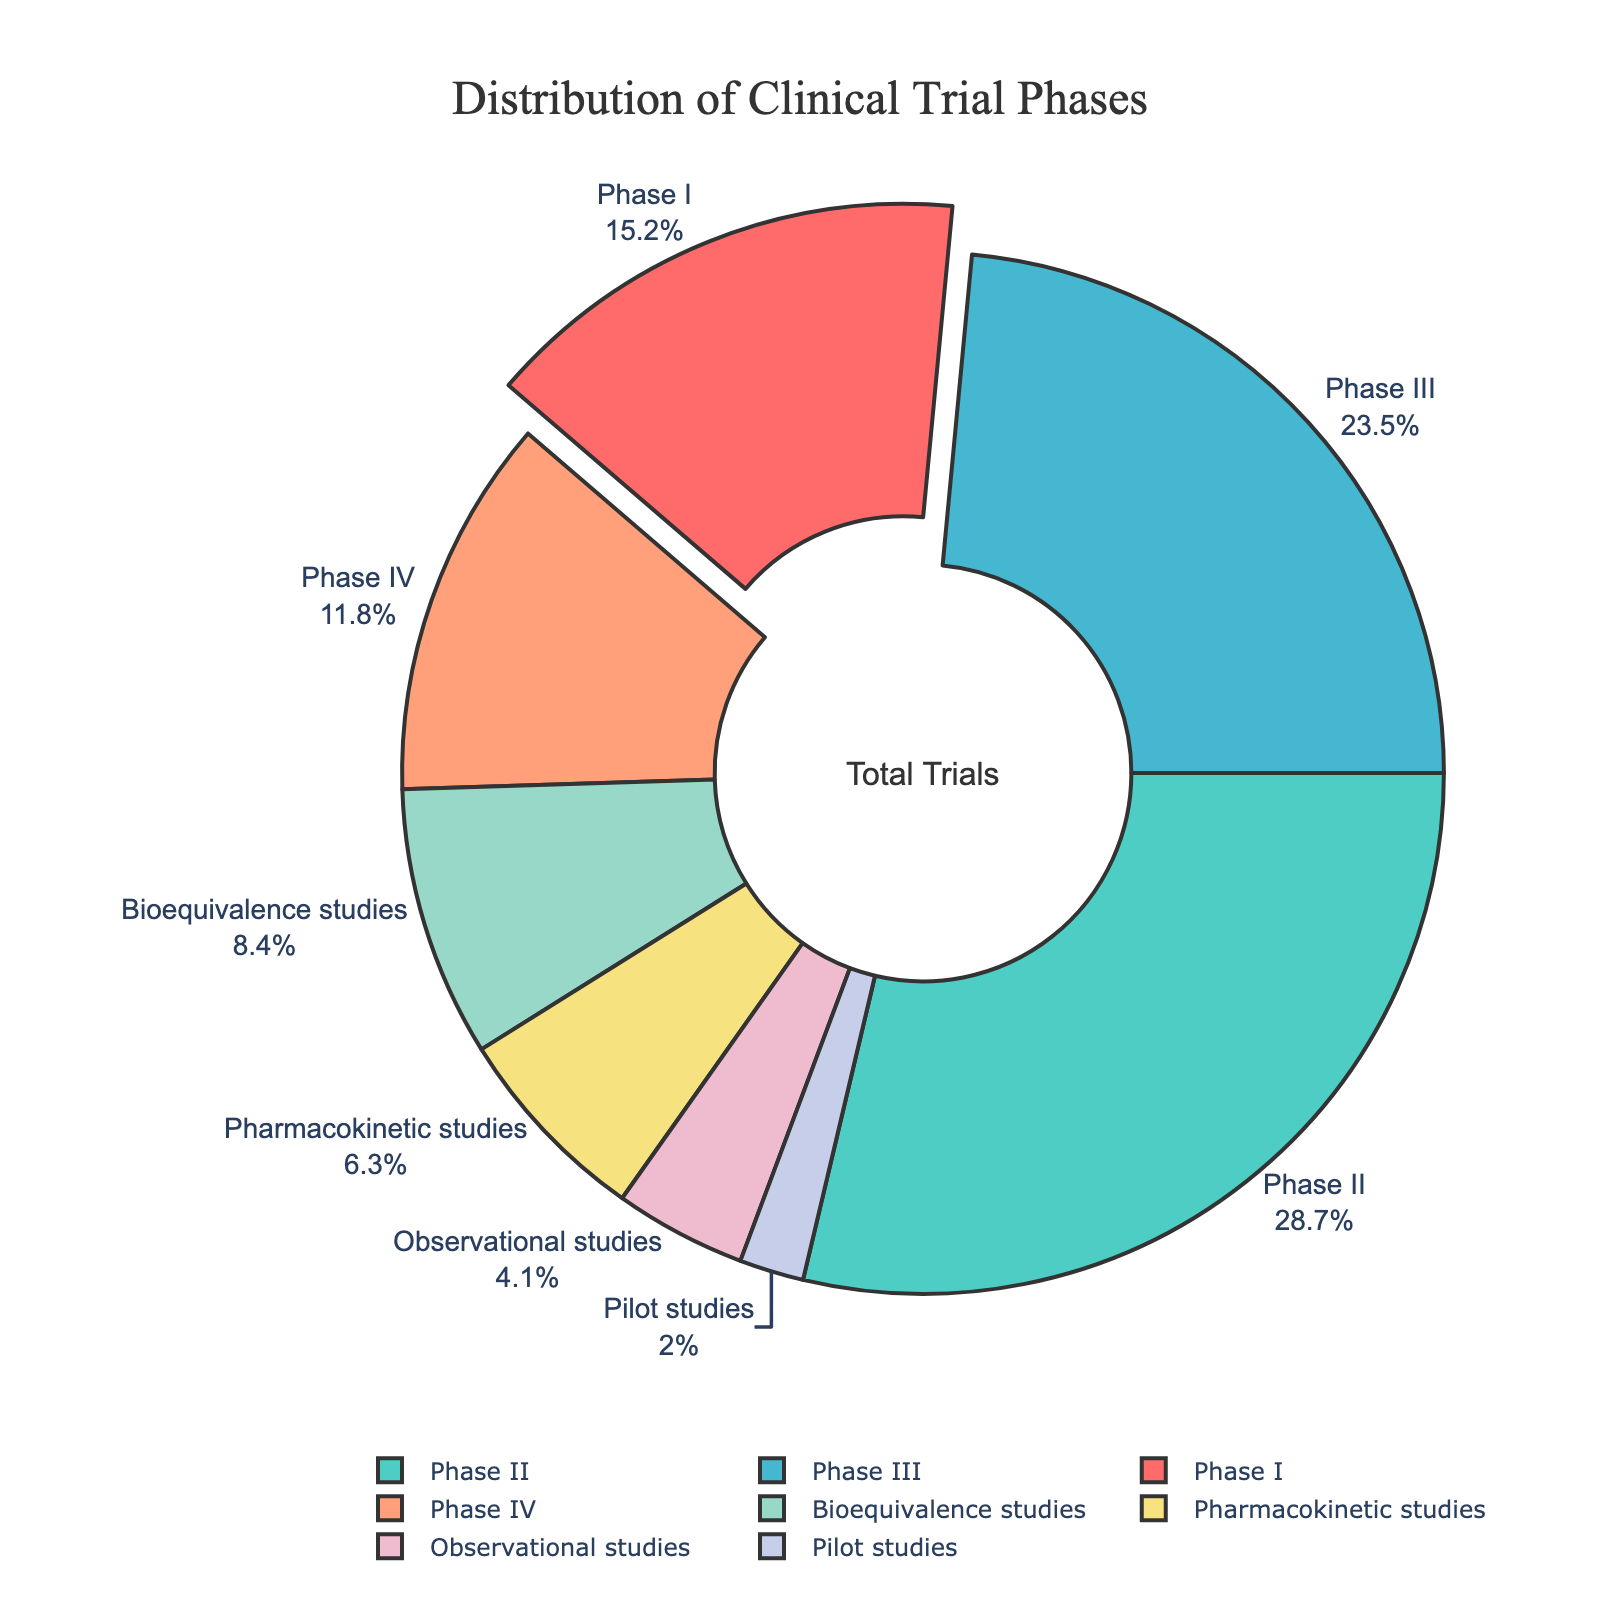What is the largest segment in the pie chart? By visually inspecting the pie chart, the largest segment corresponds to Phase II at 28.7%.
Answer: Phase II How does the percentage of Phase I trials compare to that of Phase III trials? Phase I has 15.2% while Phase III has 23.5%. Phase III has a higher percentage than Phase I.
Answer: Phase III What is the combined percentage of Bioequivalence and Pharmacokinetic studies? Bioequivalence studies account for 8.4% and Pharmacokinetic studies account for 6.3%. Adding these gives 8.4% + 6.3% = 14.7%.
Answer: 14.7% Which phase or study has the smallest representation, and what is its percentage? The smallest segment in the pie chart is for Pilot studies, which is 2.0%.
Answer: Pilot studies How many phases or studies have percentages greater than 20%? The phases with percentages greater than 20% are Phase II (28.7%) and Phase III (23.5%). Thus, there are 2.
Answer: 2 What is the sum of the percentages of clinical trial phases (Phase I to IV)? The percentages for Phase I, Phase II, Phase III, and Phase IV are 15.2%, 28.7%, 23.5%, and 11.8%, respectively. Adding these gives 15.2% + 28.7% + 23.5% + 11.8% = 79.2%.
Answer: 79.2% Which segment is highlighted (pulled out) in the pie chart? By visually inspecting the pie chart, the segment that is pulled out is Phase I.
Answer: Phase I 